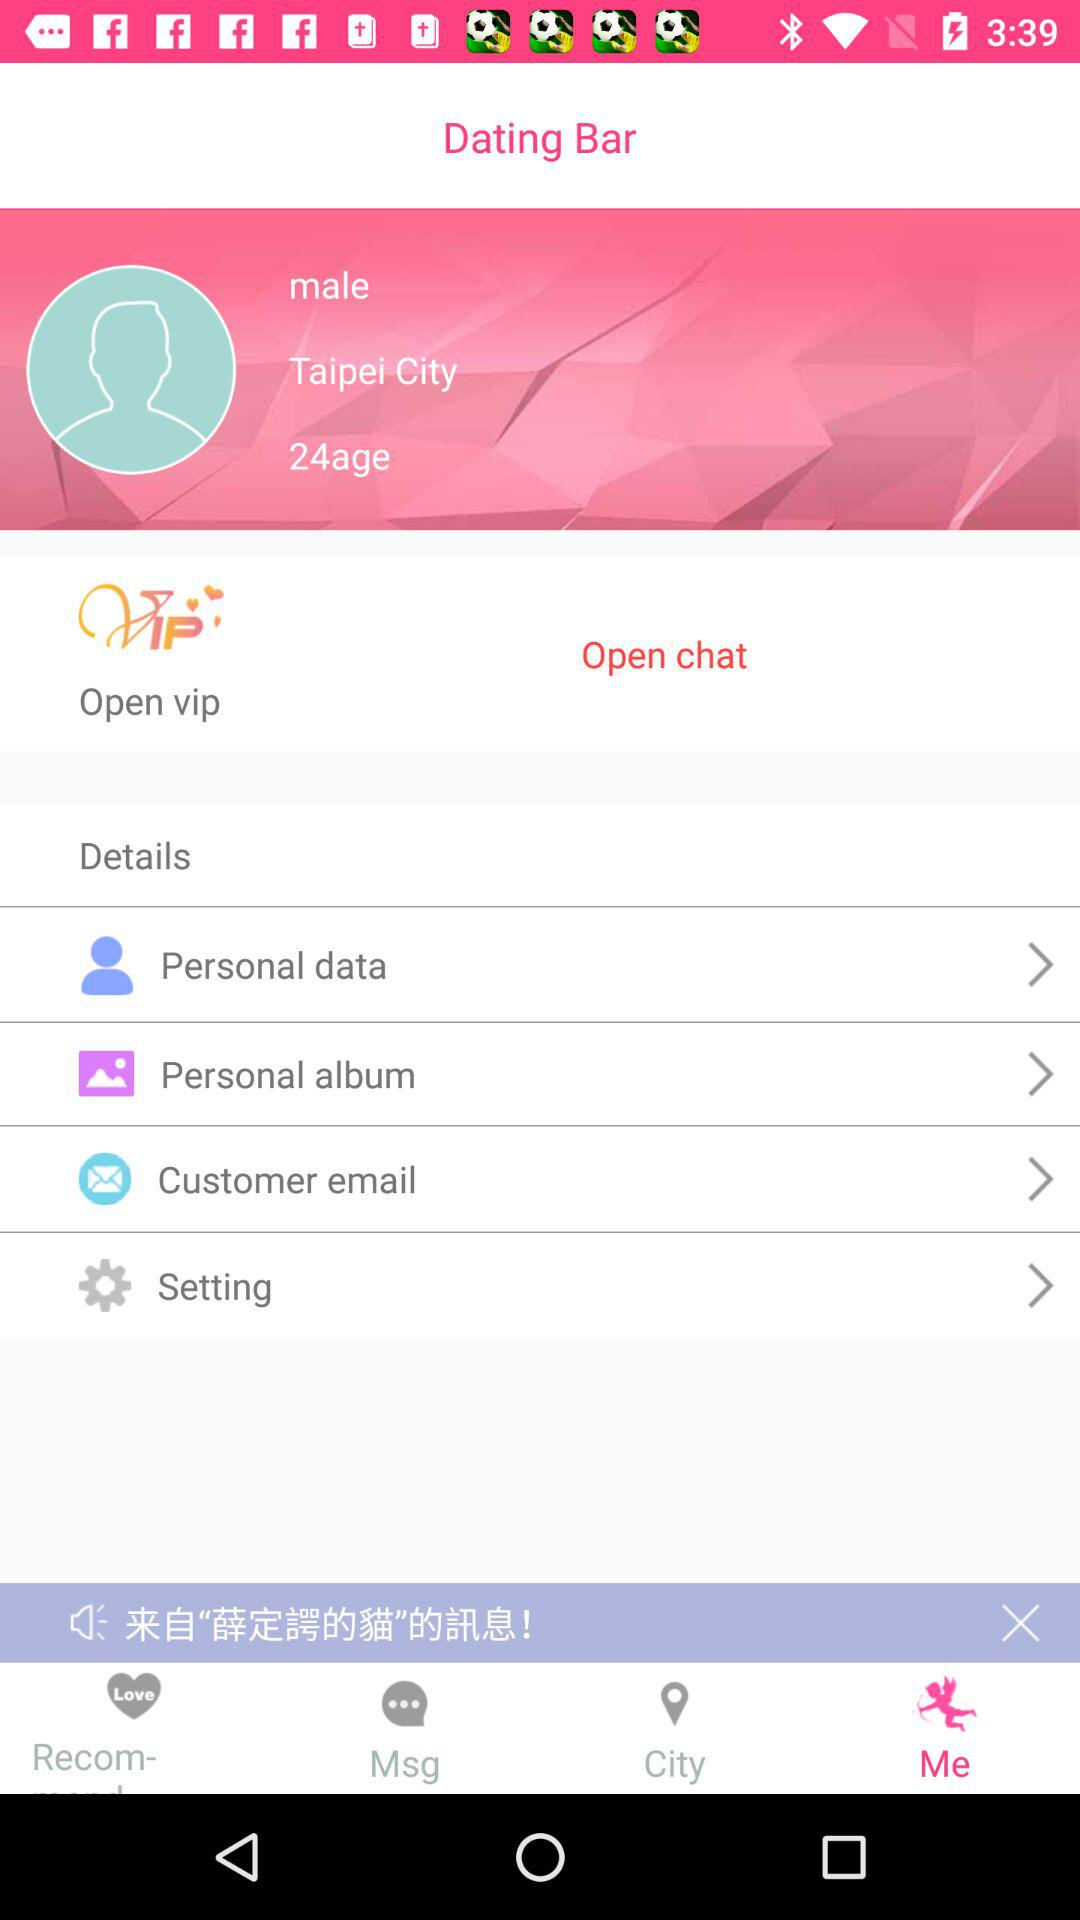What is the app name? The app name is "Dating Bar". 